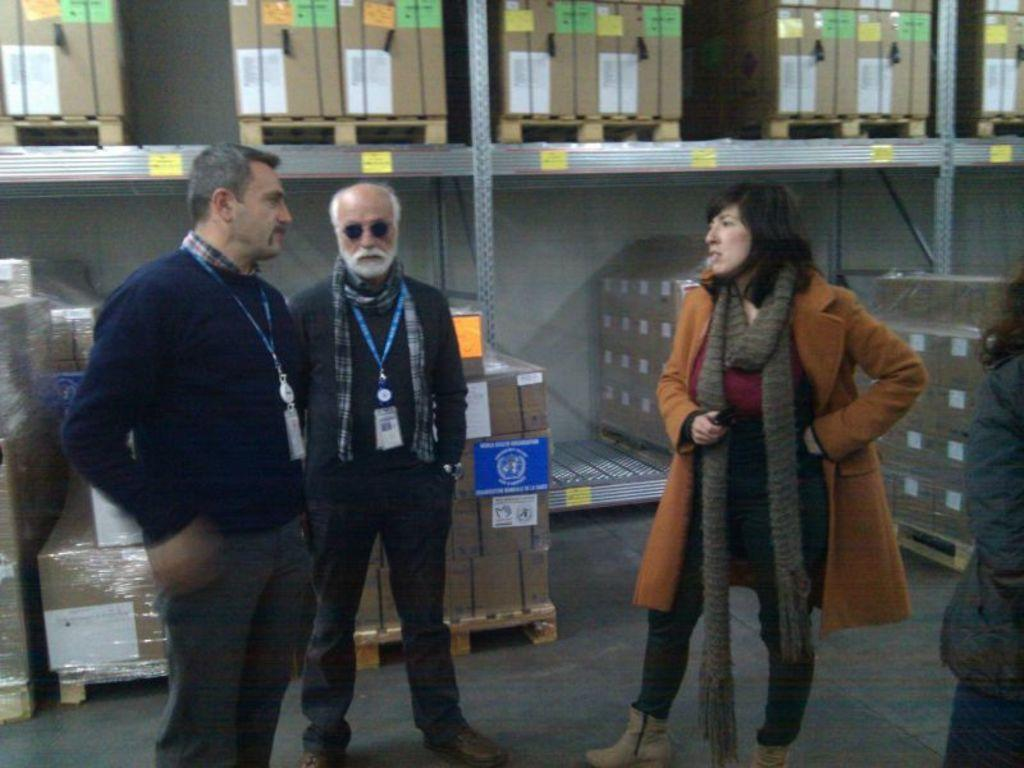What can be observed about the people in the image? There are people with different color dresses in the image. What do the identification cards signify? Two people have identification cards, which may indicate their affiliation or role. What is present in the background of the image? There are cardboard boxes in the rack in the background of the image. What type of scene is being depicted in the image? The image does not depict a specific scene; it simply shows people with different color dresses, identification cards, and cardboard boxes in the background. Is there a sink visible in the image? No, there is no sink present in the image. 